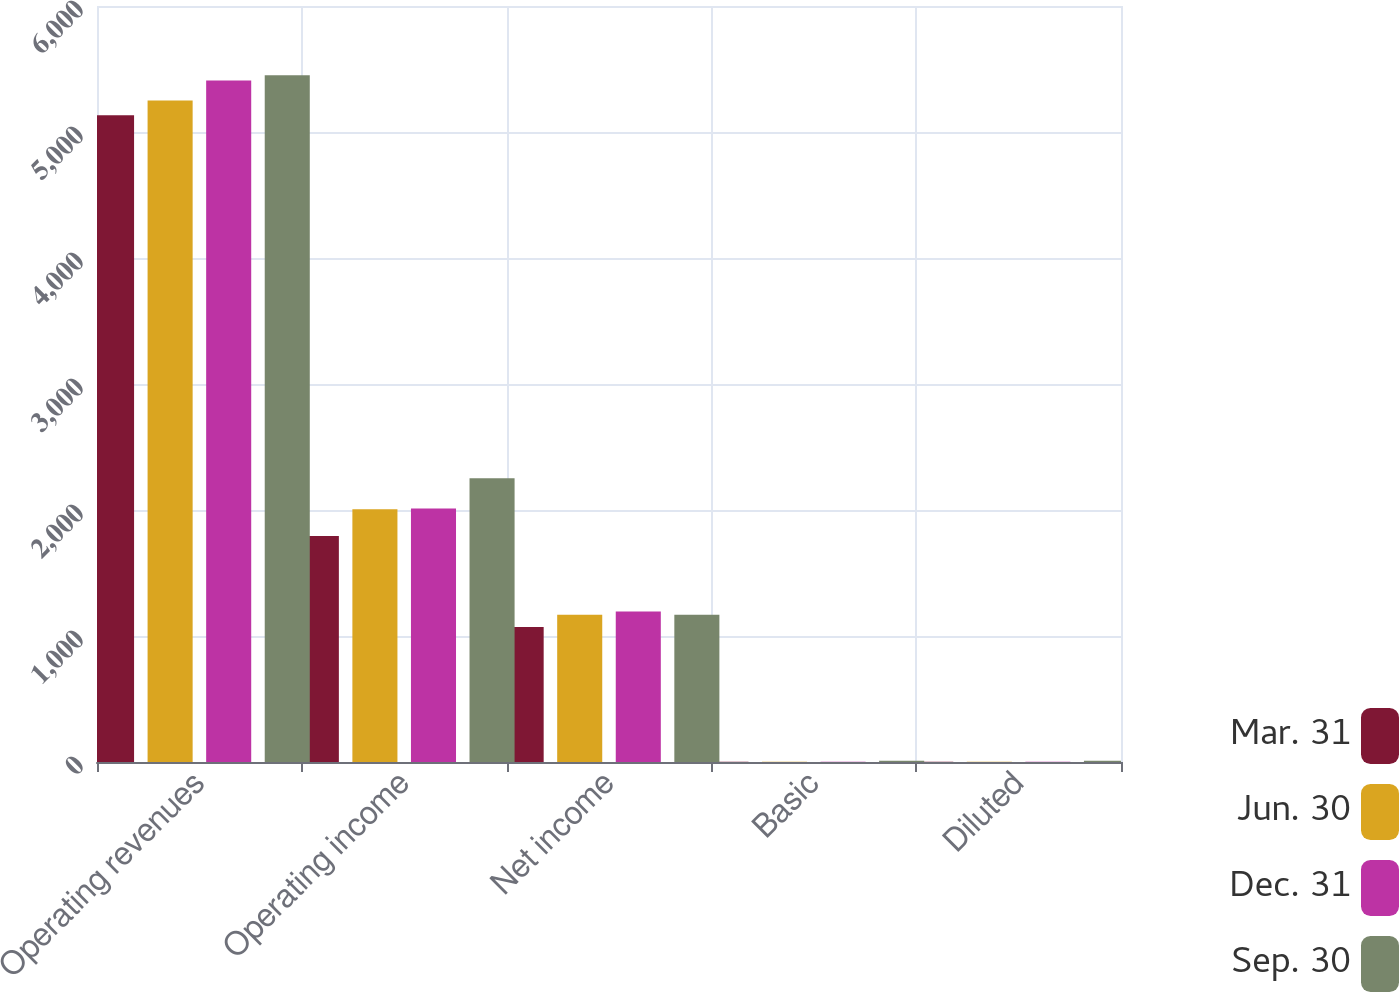Convert chart to OTSL. <chart><loc_0><loc_0><loc_500><loc_500><stacked_bar_chart><ecel><fcel>Operating revenues<fcel>Operating income<fcel>Net income<fcel>Basic<fcel>Diluted<nl><fcel>Mar. 31<fcel>5132<fcel>1793<fcel>1072<fcel>1.32<fcel>1.32<nl><fcel>Jun. 30<fcel>5250<fcel>2005<fcel>1168<fcel>1.45<fcel>1.45<nl><fcel>Dec. 31<fcel>5408<fcel>2012<fcel>1194<fcel>1.5<fcel>1.5<nl><fcel>Sep. 30<fcel>5450<fcel>2251<fcel>1168<fcel>9.29<fcel>9.25<nl></chart> 